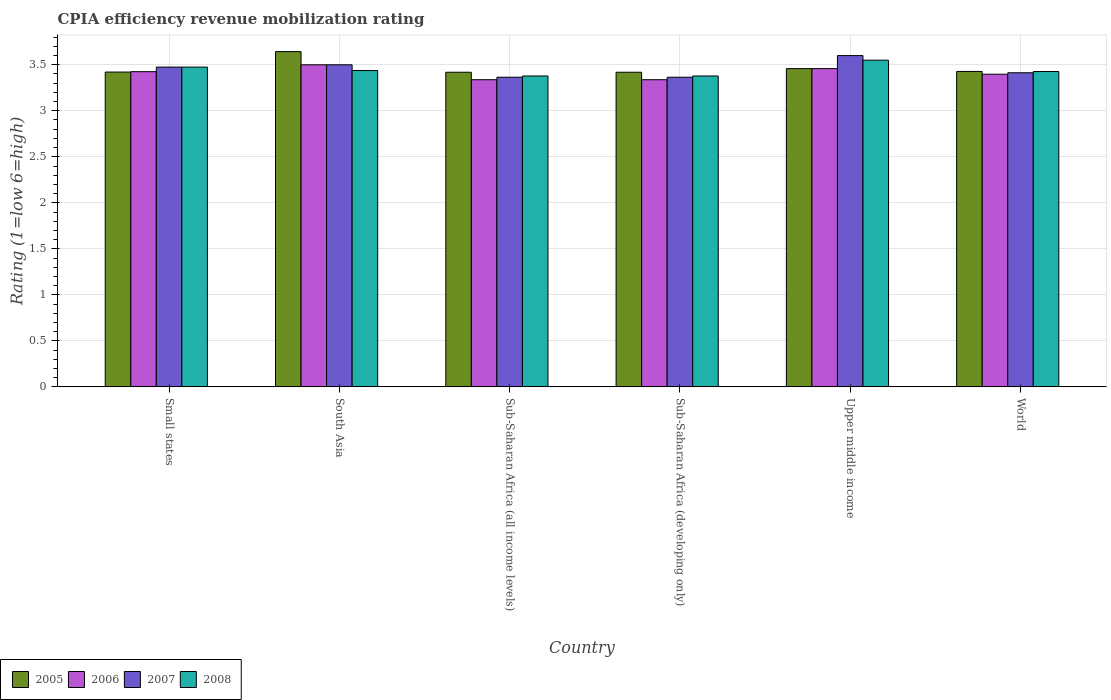How many groups of bars are there?
Provide a short and direct response. 6. Are the number of bars on each tick of the X-axis equal?
Make the answer very short. Yes. How many bars are there on the 5th tick from the left?
Give a very brief answer. 4. What is the label of the 4th group of bars from the left?
Offer a very short reply. Sub-Saharan Africa (developing only). In how many cases, is the number of bars for a given country not equal to the number of legend labels?
Ensure brevity in your answer.  0. What is the CPIA rating in 2005 in Small states?
Provide a short and direct response. 3.42. Across all countries, what is the maximum CPIA rating in 2007?
Provide a short and direct response. 3.6. Across all countries, what is the minimum CPIA rating in 2007?
Provide a succinct answer. 3.36. In which country was the CPIA rating in 2006 minimum?
Ensure brevity in your answer.  Sub-Saharan Africa (all income levels). What is the total CPIA rating in 2006 in the graph?
Make the answer very short. 20.46. What is the difference between the CPIA rating in 2006 in Sub-Saharan Africa (all income levels) and that in World?
Your answer should be very brief. -0.06. What is the difference between the CPIA rating in 2007 in Sub-Saharan Africa (developing only) and the CPIA rating in 2006 in Sub-Saharan Africa (all income levels)?
Offer a terse response. 0.03. What is the average CPIA rating in 2005 per country?
Keep it short and to the point. 3.46. What is the difference between the CPIA rating of/in 2007 and CPIA rating of/in 2005 in Sub-Saharan Africa (developing only)?
Offer a very short reply. -0.05. What is the ratio of the CPIA rating in 2005 in Sub-Saharan Africa (developing only) to that in Upper middle income?
Your answer should be compact. 0.99. Is the difference between the CPIA rating in 2007 in Small states and World greater than the difference between the CPIA rating in 2005 in Small states and World?
Make the answer very short. Yes. What is the difference between the highest and the second highest CPIA rating in 2005?
Your answer should be compact. 0.03. What is the difference between the highest and the lowest CPIA rating in 2008?
Your answer should be compact. 0.17. Is it the case that in every country, the sum of the CPIA rating in 2007 and CPIA rating in 2005 is greater than the sum of CPIA rating in 2008 and CPIA rating in 2006?
Ensure brevity in your answer.  No. What does the 4th bar from the left in South Asia represents?
Your answer should be compact. 2008. Is it the case that in every country, the sum of the CPIA rating in 2008 and CPIA rating in 2005 is greater than the CPIA rating in 2006?
Make the answer very short. Yes. How many bars are there?
Your response must be concise. 24. Are all the bars in the graph horizontal?
Offer a terse response. No. How many countries are there in the graph?
Provide a short and direct response. 6. Does the graph contain any zero values?
Keep it short and to the point. No. How are the legend labels stacked?
Your response must be concise. Horizontal. What is the title of the graph?
Offer a very short reply. CPIA efficiency revenue mobilization rating. Does "2014" appear as one of the legend labels in the graph?
Your answer should be compact. No. What is the Rating (1=low 6=high) of 2005 in Small states?
Your answer should be very brief. 3.42. What is the Rating (1=low 6=high) of 2006 in Small states?
Your response must be concise. 3.42. What is the Rating (1=low 6=high) of 2007 in Small states?
Your answer should be very brief. 3.48. What is the Rating (1=low 6=high) of 2008 in Small states?
Your answer should be compact. 3.48. What is the Rating (1=low 6=high) in 2005 in South Asia?
Provide a short and direct response. 3.64. What is the Rating (1=low 6=high) of 2008 in South Asia?
Provide a short and direct response. 3.44. What is the Rating (1=low 6=high) in 2005 in Sub-Saharan Africa (all income levels)?
Offer a terse response. 3.42. What is the Rating (1=low 6=high) of 2006 in Sub-Saharan Africa (all income levels)?
Offer a very short reply. 3.34. What is the Rating (1=low 6=high) of 2007 in Sub-Saharan Africa (all income levels)?
Give a very brief answer. 3.36. What is the Rating (1=low 6=high) of 2008 in Sub-Saharan Africa (all income levels)?
Your answer should be compact. 3.38. What is the Rating (1=low 6=high) of 2005 in Sub-Saharan Africa (developing only)?
Keep it short and to the point. 3.42. What is the Rating (1=low 6=high) in 2006 in Sub-Saharan Africa (developing only)?
Keep it short and to the point. 3.34. What is the Rating (1=low 6=high) of 2007 in Sub-Saharan Africa (developing only)?
Your answer should be compact. 3.36. What is the Rating (1=low 6=high) in 2008 in Sub-Saharan Africa (developing only)?
Your answer should be very brief. 3.38. What is the Rating (1=low 6=high) of 2005 in Upper middle income?
Your answer should be compact. 3.46. What is the Rating (1=low 6=high) in 2006 in Upper middle income?
Offer a very short reply. 3.46. What is the Rating (1=low 6=high) of 2007 in Upper middle income?
Give a very brief answer. 3.6. What is the Rating (1=low 6=high) in 2008 in Upper middle income?
Provide a succinct answer. 3.55. What is the Rating (1=low 6=high) of 2005 in World?
Provide a succinct answer. 3.43. What is the Rating (1=low 6=high) of 2006 in World?
Keep it short and to the point. 3.4. What is the Rating (1=low 6=high) in 2007 in World?
Offer a terse response. 3.41. What is the Rating (1=low 6=high) of 2008 in World?
Provide a succinct answer. 3.43. Across all countries, what is the maximum Rating (1=low 6=high) in 2005?
Offer a terse response. 3.64. Across all countries, what is the maximum Rating (1=low 6=high) in 2007?
Provide a succinct answer. 3.6. Across all countries, what is the maximum Rating (1=low 6=high) in 2008?
Make the answer very short. 3.55. Across all countries, what is the minimum Rating (1=low 6=high) in 2005?
Offer a very short reply. 3.42. Across all countries, what is the minimum Rating (1=low 6=high) of 2006?
Your answer should be compact. 3.34. Across all countries, what is the minimum Rating (1=low 6=high) of 2007?
Offer a very short reply. 3.36. Across all countries, what is the minimum Rating (1=low 6=high) of 2008?
Your answer should be compact. 3.38. What is the total Rating (1=low 6=high) of 2005 in the graph?
Provide a short and direct response. 20.79. What is the total Rating (1=low 6=high) of 2006 in the graph?
Ensure brevity in your answer.  20.46. What is the total Rating (1=low 6=high) of 2007 in the graph?
Keep it short and to the point. 20.72. What is the total Rating (1=low 6=high) of 2008 in the graph?
Your response must be concise. 20.65. What is the difference between the Rating (1=low 6=high) in 2005 in Small states and that in South Asia?
Your response must be concise. -0.22. What is the difference between the Rating (1=low 6=high) in 2006 in Small states and that in South Asia?
Your answer should be very brief. -0.07. What is the difference between the Rating (1=low 6=high) of 2007 in Small states and that in South Asia?
Offer a terse response. -0.03. What is the difference between the Rating (1=low 6=high) of 2008 in Small states and that in South Asia?
Make the answer very short. 0.04. What is the difference between the Rating (1=low 6=high) in 2005 in Small states and that in Sub-Saharan Africa (all income levels)?
Give a very brief answer. 0. What is the difference between the Rating (1=low 6=high) of 2006 in Small states and that in Sub-Saharan Africa (all income levels)?
Your response must be concise. 0.09. What is the difference between the Rating (1=low 6=high) of 2007 in Small states and that in Sub-Saharan Africa (all income levels)?
Give a very brief answer. 0.11. What is the difference between the Rating (1=low 6=high) of 2008 in Small states and that in Sub-Saharan Africa (all income levels)?
Provide a succinct answer. 0.1. What is the difference between the Rating (1=low 6=high) in 2005 in Small states and that in Sub-Saharan Africa (developing only)?
Keep it short and to the point. 0. What is the difference between the Rating (1=low 6=high) of 2006 in Small states and that in Sub-Saharan Africa (developing only)?
Keep it short and to the point. 0.09. What is the difference between the Rating (1=low 6=high) in 2007 in Small states and that in Sub-Saharan Africa (developing only)?
Ensure brevity in your answer.  0.11. What is the difference between the Rating (1=low 6=high) in 2008 in Small states and that in Sub-Saharan Africa (developing only)?
Provide a short and direct response. 0.1. What is the difference between the Rating (1=low 6=high) in 2005 in Small states and that in Upper middle income?
Make the answer very short. -0.04. What is the difference between the Rating (1=low 6=high) of 2006 in Small states and that in Upper middle income?
Your answer should be compact. -0.03. What is the difference between the Rating (1=low 6=high) in 2007 in Small states and that in Upper middle income?
Offer a terse response. -0.12. What is the difference between the Rating (1=low 6=high) of 2008 in Small states and that in Upper middle income?
Provide a succinct answer. -0.07. What is the difference between the Rating (1=low 6=high) in 2005 in Small states and that in World?
Offer a very short reply. -0.01. What is the difference between the Rating (1=low 6=high) in 2006 in Small states and that in World?
Your response must be concise. 0.03. What is the difference between the Rating (1=low 6=high) in 2007 in Small states and that in World?
Provide a succinct answer. 0.06. What is the difference between the Rating (1=low 6=high) of 2008 in Small states and that in World?
Your response must be concise. 0.05. What is the difference between the Rating (1=low 6=high) of 2005 in South Asia and that in Sub-Saharan Africa (all income levels)?
Ensure brevity in your answer.  0.22. What is the difference between the Rating (1=low 6=high) of 2006 in South Asia and that in Sub-Saharan Africa (all income levels)?
Provide a succinct answer. 0.16. What is the difference between the Rating (1=low 6=high) in 2007 in South Asia and that in Sub-Saharan Africa (all income levels)?
Your answer should be compact. 0.14. What is the difference between the Rating (1=low 6=high) of 2008 in South Asia and that in Sub-Saharan Africa (all income levels)?
Your answer should be compact. 0.06. What is the difference between the Rating (1=low 6=high) of 2005 in South Asia and that in Sub-Saharan Africa (developing only)?
Your answer should be compact. 0.22. What is the difference between the Rating (1=low 6=high) in 2006 in South Asia and that in Sub-Saharan Africa (developing only)?
Ensure brevity in your answer.  0.16. What is the difference between the Rating (1=low 6=high) of 2007 in South Asia and that in Sub-Saharan Africa (developing only)?
Offer a terse response. 0.14. What is the difference between the Rating (1=low 6=high) of 2008 in South Asia and that in Sub-Saharan Africa (developing only)?
Your answer should be very brief. 0.06. What is the difference between the Rating (1=low 6=high) of 2005 in South Asia and that in Upper middle income?
Give a very brief answer. 0.18. What is the difference between the Rating (1=low 6=high) in 2006 in South Asia and that in Upper middle income?
Offer a terse response. 0.04. What is the difference between the Rating (1=low 6=high) in 2008 in South Asia and that in Upper middle income?
Give a very brief answer. -0.11. What is the difference between the Rating (1=low 6=high) in 2005 in South Asia and that in World?
Ensure brevity in your answer.  0.22. What is the difference between the Rating (1=low 6=high) of 2006 in South Asia and that in World?
Ensure brevity in your answer.  0.1. What is the difference between the Rating (1=low 6=high) in 2007 in South Asia and that in World?
Offer a terse response. 0.09. What is the difference between the Rating (1=low 6=high) of 2008 in South Asia and that in World?
Your answer should be very brief. 0.01. What is the difference between the Rating (1=low 6=high) of 2005 in Sub-Saharan Africa (all income levels) and that in Sub-Saharan Africa (developing only)?
Your response must be concise. 0. What is the difference between the Rating (1=low 6=high) in 2007 in Sub-Saharan Africa (all income levels) and that in Sub-Saharan Africa (developing only)?
Your answer should be compact. 0. What is the difference between the Rating (1=low 6=high) in 2008 in Sub-Saharan Africa (all income levels) and that in Sub-Saharan Africa (developing only)?
Your response must be concise. 0. What is the difference between the Rating (1=low 6=high) in 2005 in Sub-Saharan Africa (all income levels) and that in Upper middle income?
Offer a terse response. -0.04. What is the difference between the Rating (1=low 6=high) of 2006 in Sub-Saharan Africa (all income levels) and that in Upper middle income?
Ensure brevity in your answer.  -0.12. What is the difference between the Rating (1=low 6=high) of 2007 in Sub-Saharan Africa (all income levels) and that in Upper middle income?
Make the answer very short. -0.24. What is the difference between the Rating (1=low 6=high) in 2008 in Sub-Saharan Africa (all income levels) and that in Upper middle income?
Give a very brief answer. -0.17. What is the difference between the Rating (1=low 6=high) of 2005 in Sub-Saharan Africa (all income levels) and that in World?
Offer a terse response. -0.01. What is the difference between the Rating (1=low 6=high) in 2006 in Sub-Saharan Africa (all income levels) and that in World?
Your response must be concise. -0.06. What is the difference between the Rating (1=low 6=high) of 2007 in Sub-Saharan Africa (all income levels) and that in World?
Ensure brevity in your answer.  -0.05. What is the difference between the Rating (1=low 6=high) of 2008 in Sub-Saharan Africa (all income levels) and that in World?
Give a very brief answer. -0.05. What is the difference between the Rating (1=low 6=high) of 2005 in Sub-Saharan Africa (developing only) and that in Upper middle income?
Your answer should be compact. -0.04. What is the difference between the Rating (1=low 6=high) in 2006 in Sub-Saharan Africa (developing only) and that in Upper middle income?
Your response must be concise. -0.12. What is the difference between the Rating (1=low 6=high) of 2007 in Sub-Saharan Africa (developing only) and that in Upper middle income?
Your response must be concise. -0.24. What is the difference between the Rating (1=low 6=high) of 2008 in Sub-Saharan Africa (developing only) and that in Upper middle income?
Make the answer very short. -0.17. What is the difference between the Rating (1=low 6=high) in 2005 in Sub-Saharan Africa (developing only) and that in World?
Ensure brevity in your answer.  -0.01. What is the difference between the Rating (1=low 6=high) in 2006 in Sub-Saharan Africa (developing only) and that in World?
Ensure brevity in your answer.  -0.06. What is the difference between the Rating (1=low 6=high) in 2007 in Sub-Saharan Africa (developing only) and that in World?
Offer a terse response. -0.05. What is the difference between the Rating (1=low 6=high) in 2008 in Sub-Saharan Africa (developing only) and that in World?
Give a very brief answer. -0.05. What is the difference between the Rating (1=low 6=high) of 2005 in Upper middle income and that in World?
Make the answer very short. 0.03. What is the difference between the Rating (1=low 6=high) in 2006 in Upper middle income and that in World?
Provide a short and direct response. 0.06. What is the difference between the Rating (1=low 6=high) in 2007 in Upper middle income and that in World?
Give a very brief answer. 0.19. What is the difference between the Rating (1=low 6=high) of 2008 in Upper middle income and that in World?
Your answer should be very brief. 0.12. What is the difference between the Rating (1=low 6=high) in 2005 in Small states and the Rating (1=low 6=high) in 2006 in South Asia?
Keep it short and to the point. -0.08. What is the difference between the Rating (1=low 6=high) of 2005 in Small states and the Rating (1=low 6=high) of 2007 in South Asia?
Provide a succinct answer. -0.08. What is the difference between the Rating (1=low 6=high) in 2005 in Small states and the Rating (1=low 6=high) in 2008 in South Asia?
Your answer should be very brief. -0.02. What is the difference between the Rating (1=low 6=high) of 2006 in Small states and the Rating (1=low 6=high) of 2007 in South Asia?
Your answer should be compact. -0.07. What is the difference between the Rating (1=low 6=high) of 2006 in Small states and the Rating (1=low 6=high) of 2008 in South Asia?
Make the answer very short. -0.01. What is the difference between the Rating (1=low 6=high) of 2007 in Small states and the Rating (1=low 6=high) of 2008 in South Asia?
Your answer should be very brief. 0.04. What is the difference between the Rating (1=low 6=high) of 2005 in Small states and the Rating (1=low 6=high) of 2006 in Sub-Saharan Africa (all income levels)?
Provide a succinct answer. 0.08. What is the difference between the Rating (1=low 6=high) of 2005 in Small states and the Rating (1=low 6=high) of 2007 in Sub-Saharan Africa (all income levels)?
Ensure brevity in your answer.  0.06. What is the difference between the Rating (1=low 6=high) in 2005 in Small states and the Rating (1=low 6=high) in 2008 in Sub-Saharan Africa (all income levels)?
Your answer should be compact. 0.04. What is the difference between the Rating (1=low 6=high) in 2006 in Small states and the Rating (1=low 6=high) in 2007 in Sub-Saharan Africa (all income levels)?
Provide a short and direct response. 0.06. What is the difference between the Rating (1=low 6=high) of 2006 in Small states and the Rating (1=low 6=high) of 2008 in Sub-Saharan Africa (all income levels)?
Your response must be concise. 0.05. What is the difference between the Rating (1=low 6=high) of 2007 in Small states and the Rating (1=low 6=high) of 2008 in Sub-Saharan Africa (all income levels)?
Your answer should be very brief. 0.1. What is the difference between the Rating (1=low 6=high) of 2005 in Small states and the Rating (1=low 6=high) of 2006 in Sub-Saharan Africa (developing only)?
Offer a terse response. 0.08. What is the difference between the Rating (1=low 6=high) of 2005 in Small states and the Rating (1=low 6=high) of 2007 in Sub-Saharan Africa (developing only)?
Ensure brevity in your answer.  0.06. What is the difference between the Rating (1=low 6=high) in 2005 in Small states and the Rating (1=low 6=high) in 2008 in Sub-Saharan Africa (developing only)?
Your response must be concise. 0.04. What is the difference between the Rating (1=low 6=high) of 2006 in Small states and the Rating (1=low 6=high) of 2007 in Sub-Saharan Africa (developing only)?
Ensure brevity in your answer.  0.06. What is the difference between the Rating (1=low 6=high) of 2006 in Small states and the Rating (1=low 6=high) of 2008 in Sub-Saharan Africa (developing only)?
Your answer should be very brief. 0.05. What is the difference between the Rating (1=low 6=high) in 2007 in Small states and the Rating (1=low 6=high) in 2008 in Sub-Saharan Africa (developing only)?
Your response must be concise. 0.1. What is the difference between the Rating (1=low 6=high) in 2005 in Small states and the Rating (1=low 6=high) in 2006 in Upper middle income?
Offer a very short reply. -0.04. What is the difference between the Rating (1=low 6=high) of 2005 in Small states and the Rating (1=low 6=high) of 2007 in Upper middle income?
Your answer should be compact. -0.18. What is the difference between the Rating (1=low 6=high) in 2005 in Small states and the Rating (1=low 6=high) in 2008 in Upper middle income?
Your answer should be very brief. -0.13. What is the difference between the Rating (1=low 6=high) in 2006 in Small states and the Rating (1=low 6=high) in 2007 in Upper middle income?
Give a very brief answer. -0.17. What is the difference between the Rating (1=low 6=high) in 2006 in Small states and the Rating (1=low 6=high) in 2008 in Upper middle income?
Your answer should be compact. -0.12. What is the difference between the Rating (1=low 6=high) of 2007 in Small states and the Rating (1=low 6=high) of 2008 in Upper middle income?
Your answer should be compact. -0.07. What is the difference between the Rating (1=low 6=high) of 2005 in Small states and the Rating (1=low 6=high) of 2006 in World?
Offer a very short reply. 0.02. What is the difference between the Rating (1=low 6=high) in 2005 in Small states and the Rating (1=low 6=high) in 2007 in World?
Provide a short and direct response. 0.01. What is the difference between the Rating (1=low 6=high) of 2005 in Small states and the Rating (1=low 6=high) of 2008 in World?
Make the answer very short. -0.01. What is the difference between the Rating (1=low 6=high) in 2006 in Small states and the Rating (1=low 6=high) in 2007 in World?
Your answer should be compact. 0.01. What is the difference between the Rating (1=low 6=high) of 2006 in Small states and the Rating (1=low 6=high) of 2008 in World?
Your answer should be very brief. -0. What is the difference between the Rating (1=low 6=high) in 2007 in Small states and the Rating (1=low 6=high) in 2008 in World?
Ensure brevity in your answer.  0.05. What is the difference between the Rating (1=low 6=high) in 2005 in South Asia and the Rating (1=low 6=high) in 2006 in Sub-Saharan Africa (all income levels)?
Give a very brief answer. 0.3. What is the difference between the Rating (1=low 6=high) in 2005 in South Asia and the Rating (1=low 6=high) in 2007 in Sub-Saharan Africa (all income levels)?
Give a very brief answer. 0.28. What is the difference between the Rating (1=low 6=high) in 2005 in South Asia and the Rating (1=low 6=high) in 2008 in Sub-Saharan Africa (all income levels)?
Your answer should be very brief. 0.26. What is the difference between the Rating (1=low 6=high) in 2006 in South Asia and the Rating (1=low 6=high) in 2007 in Sub-Saharan Africa (all income levels)?
Provide a succinct answer. 0.14. What is the difference between the Rating (1=low 6=high) in 2006 in South Asia and the Rating (1=low 6=high) in 2008 in Sub-Saharan Africa (all income levels)?
Provide a succinct answer. 0.12. What is the difference between the Rating (1=low 6=high) in 2007 in South Asia and the Rating (1=low 6=high) in 2008 in Sub-Saharan Africa (all income levels)?
Your answer should be compact. 0.12. What is the difference between the Rating (1=low 6=high) in 2005 in South Asia and the Rating (1=low 6=high) in 2006 in Sub-Saharan Africa (developing only)?
Make the answer very short. 0.3. What is the difference between the Rating (1=low 6=high) in 2005 in South Asia and the Rating (1=low 6=high) in 2007 in Sub-Saharan Africa (developing only)?
Ensure brevity in your answer.  0.28. What is the difference between the Rating (1=low 6=high) of 2005 in South Asia and the Rating (1=low 6=high) of 2008 in Sub-Saharan Africa (developing only)?
Provide a short and direct response. 0.26. What is the difference between the Rating (1=low 6=high) in 2006 in South Asia and the Rating (1=low 6=high) in 2007 in Sub-Saharan Africa (developing only)?
Give a very brief answer. 0.14. What is the difference between the Rating (1=low 6=high) in 2006 in South Asia and the Rating (1=low 6=high) in 2008 in Sub-Saharan Africa (developing only)?
Offer a terse response. 0.12. What is the difference between the Rating (1=low 6=high) in 2007 in South Asia and the Rating (1=low 6=high) in 2008 in Sub-Saharan Africa (developing only)?
Provide a short and direct response. 0.12. What is the difference between the Rating (1=low 6=high) of 2005 in South Asia and the Rating (1=low 6=high) of 2006 in Upper middle income?
Provide a short and direct response. 0.18. What is the difference between the Rating (1=low 6=high) of 2005 in South Asia and the Rating (1=low 6=high) of 2007 in Upper middle income?
Provide a short and direct response. 0.04. What is the difference between the Rating (1=low 6=high) of 2005 in South Asia and the Rating (1=low 6=high) of 2008 in Upper middle income?
Your answer should be compact. 0.09. What is the difference between the Rating (1=low 6=high) of 2006 in South Asia and the Rating (1=low 6=high) of 2008 in Upper middle income?
Provide a succinct answer. -0.05. What is the difference between the Rating (1=low 6=high) in 2005 in South Asia and the Rating (1=low 6=high) in 2006 in World?
Make the answer very short. 0.25. What is the difference between the Rating (1=low 6=high) in 2005 in South Asia and the Rating (1=low 6=high) in 2007 in World?
Offer a very short reply. 0.23. What is the difference between the Rating (1=low 6=high) of 2005 in South Asia and the Rating (1=low 6=high) of 2008 in World?
Provide a short and direct response. 0.22. What is the difference between the Rating (1=low 6=high) of 2006 in South Asia and the Rating (1=low 6=high) of 2007 in World?
Your answer should be very brief. 0.09. What is the difference between the Rating (1=low 6=high) in 2006 in South Asia and the Rating (1=low 6=high) in 2008 in World?
Keep it short and to the point. 0.07. What is the difference between the Rating (1=low 6=high) in 2007 in South Asia and the Rating (1=low 6=high) in 2008 in World?
Give a very brief answer. 0.07. What is the difference between the Rating (1=low 6=high) of 2005 in Sub-Saharan Africa (all income levels) and the Rating (1=low 6=high) of 2006 in Sub-Saharan Africa (developing only)?
Offer a very short reply. 0.08. What is the difference between the Rating (1=low 6=high) of 2005 in Sub-Saharan Africa (all income levels) and the Rating (1=low 6=high) of 2007 in Sub-Saharan Africa (developing only)?
Your answer should be very brief. 0.05. What is the difference between the Rating (1=low 6=high) in 2005 in Sub-Saharan Africa (all income levels) and the Rating (1=low 6=high) in 2008 in Sub-Saharan Africa (developing only)?
Offer a very short reply. 0.04. What is the difference between the Rating (1=low 6=high) of 2006 in Sub-Saharan Africa (all income levels) and the Rating (1=low 6=high) of 2007 in Sub-Saharan Africa (developing only)?
Give a very brief answer. -0.03. What is the difference between the Rating (1=low 6=high) in 2006 in Sub-Saharan Africa (all income levels) and the Rating (1=low 6=high) in 2008 in Sub-Saharan Africa (developing only)?
Provide a short and direct response. -0.04. What is the difference between the Rating (1=low 6=high) of 2007 in Sub-Saharan Africa (all income levels) and the Rating (1=low 6=high) of 2008 in Sub-Saharan Africa (developing only)?
Provide a short and direct response. -0.01. What is the difference between the Rating (1=low 6=high) in 2005 in Sub-Saharan Africa (all income levels) and the Rating (1=low 6=high) in 2006 in Upper middle income?
Ensure brevity in your answer.  -0.04. What is the difference between the Rating (1=low 6=high) in 2005 in Sub-Saharan Africa (all income levels) and the Rating (1=low 6=high) in 2007 in Upper middle income?
Make the answer very short. -0.18. What is the difference between the Rating (1=low 6=high) in 2005 in Sub-Saharan Africa (all income levels) and the Rating (1=low 6=high) in 2008 in Upper middle income?
Offer a very short reply. -0.13. What is the difference between the Rating (1=low 6=high) in 2006 in Sub-Saharan Africa (all income levels) and the Rating (1=low 6=high) in 2007 in Upper middle income?
Make the answer very short. -0.26. What is the difference between the Rating (1=low 6=high) of 2006 in Sub-Saharan Africa (all income levels) and the Rating (1=low 6=high) of 2008 in Upper middle income?
Offer a very short reply. -0.21. What is the difference between the Rating (1=low 6=high) of 2007 in Sub-Saharan Africa (all income levels) and the Rating (1=low 6=high) of 2008 in Upper middle income?
Make the answer very short. -0.19. What is the difference between the Rating (1=low 6=high) in 2005 in Sub-Saharan Africa (all income levels) and the Rating (1=low 6=high) in 2006 in World?
Your answer should be compact. 0.02. What is the difference between the Rating (1=low 6=high) of 2005 in Sub-Saharan Africa (all income levels) and the Rating (1=low 6=high) of 2007 in World?
Offer a very short reply. 0.01. What is the difference between the Rating (1=low 6=high) in 2005 in Sub-Saharan Africa (all income levels) and the Rating (1=low 6=high) in 2008 in World?
Ensure brevity in your answer.  -0.01. What is the difference between the Rating (1=low 6=high) of 2006 in Sub-Saharan Africa (all income levels) and the Rating (1=low 6=high) of 2007 in World?
Keep it short and to the point. -0.08. What is the difference between the Rating (1=low 6=high) of 2006 in Sub-Saharan Africa (all income levels) and the Rating (1=low 6=high) of 2008 in World?
Your answer should be compact. -0.09. What is the difference between the Rating (1=low 6=high) of 2007 in Sub-Saharan Africa (all income levels) and the Rating (1=low 6=high) of 2008 in World?
Make the answer very short. -0.06. What is the difference between the Rating (1=low 6=high) of 2005 in Sub-Saharan Africa (developing only) and the Rating (1=low 6=high) of 2006 in Upper middle income?
Provide a short and direct response. -0.04. What is the difference between the Rating (1=low 6=high) of 2005 in Sub-Saharan Africa (developing only) and the Rating (1=low 6=high) of 2007 in Upper middle income?
Keep it short and to the point. -0.18. What is the difference between the Rating (1=low 6=high) of 2005 in Sub-Saharan Africa (developing only) and the Rating (1=low 6=high) of 2008 in Upper middle income?
Provide a succinct answer. -0.13. What is the difference between the Rating (1=low 6=high) of 2006 in Sub-Saharan Africa (developing only) and the Rating (1=low 6=high) of 2007 in Upper middle income?
Give a very brief answer. -0.26. What is the difference between the Rating (1=low 6=high) of 2006 in Sub-Saharan Africa (developing only) and the Rating (1=low 6=high) of 2008 in Upper middle income?
Provide a short and direct response. -0.21. What is the difference between the Rating (1=low 6=high) of 2007 in Sub-Saharan Africa (developing only) and the Rating (1=low 6=high) of 2008 in Upper middle income?
Your answer should be very brief. -0.19. What is the difference between the Rating (1=low 6=high) of 2005 in Sub-Saharan Africa (developing only) and the Rating (1=low 6=high) of 2006 in World?
Offer a terse response. 0.02. What is the difference between the Rating (1=low 6=high) in 2005 in Sub-Saharan Africa (developing only) and the Rating (1=low 6=high) in 2007 in World?
Your answer should be very brief. 0.01. What is the difference between the Rating (1=low 6=high) in 2005 in Sub-Saharan Africa (developing only) and the Rating (1=low 6=high) in 2008 in World?
Provide a succinct answer. -0.01. What is the difference between the Rating (1=low 6=high) in 2006 in Sub-Saharan Africa (developing only) and the Rating (1=low 6=high) in 2007 in World?
Provide a short and direct response. -0.08. What is the difference between the Rating (1=low 6=high) in 2006 in Sub-Saharan Africa (developing only) and the Rating (1=low 6=high) in 2008 in World?
Your answer should be very brief. -0.09. What is the difference between the Rating (1=low 6=high) in 2007 in Sub-Saharan Africa (developing only) and the Rating (1=low 6=high) in 2008 in World?
Provide a succinct answer. -0.06. What is the difference between the Rating (1=low 6=high) in 2005 in Upper middle income and the Rating (1=low 6=high) in 2006 in World?
Provide a succinct answer. 0.06. What is the difference between the Rating (1=low 6=high) in 2005 in Upper middle income and the Rating (1=low 6=high) in 2007 in World?
Keep it short and to the point. 0.04. What is the difference between the Rating (1=low 6=high) in 2005 in Upper middle income and the Rating (1=low 6=high) in 2008 in World?
Provide a short and direct response. 0.03. What is the difference between the Rating (1=low 6=high) in 2006 in Upper middle income and the Rating (1=low 6=high) in 2007 in World?
Keep it short and to the point. 0.04. What is the difference between the Rating (1=low 6=high) in 2006 in Upper middle income and the Rating (1=low 6=high) in 2008 in World?
Ensure brevity in your answer.  0.03. What is the difference between the Rating (1=low 6=high) in 2007 in Upper middle income and the Rating (1=low 6=high) in 2008 in World?
Provide a short and direct response. 0.17. What is the average Rating (1=low 6=high) in 2005 per country?
Offer a very short reply. 3.46. What is the average Rating (1=low 6=high) of 2006 per country?
Offer a terse response. 3.41. What is the average Rating (1=low 6=high) in 2007 per country?
Offer a terse response. 3.45. What is the average Rating (1=low 6=high) of 2008 per country?
Provide a short and direct response. 3.44. What is the difference between the Rating (1=low 6=high) in 2005 and Rating (1=low 6=high) in 2006 in Small states?
Provide a succinct answer. -0. What is the difference between the Rating (1=low 6=high) of 2005 and Rating (1=low 6=high) of 2007 in Small states?
Keep it short and to the point. -0.05. What is the difference between the Rating (1=low 6=high) of 2005 and Rating (1=low 6=high) of 2008 in Small states?
Provide a short and direct response. -0.05. What is the difference between the Rating (1=low 6=high) in 2005 and Rating (1=low 6=high) in 2006 in South Asia?
Give a very brief answer. 0.14. What is the difference between the Rating (1=low 6=high) of 2005 and Rating (1=low 6=high) of 2007 in South Asia?
Your answer should be compact. 0.14. What is the difference between the Rating (1=low 6=high) of 2005 and Rating (1=low 6=high) of 2008 in South Asia?
Give a very brief answer. 0.21. What is the difference between the Rating (1=low 6=high) of 2006 and Rating (1=low 6=high) of 2008 in South Asia?
Your response must be concise. 0.06. What is the difference between the Rating (1=low 6=high) of 2007 and Rating (1=low 6=high) of 2008 in South Asia?
Your response must be concise. 0.06. What is the difference between the Rating (1=low 6=high) in 2005 and Rating (1=low 6=high) in 2006 in Sub-Saharan Africa (all income levels)?
Provide a short and direct response. 0.08. What is the difference between the Rating (1=low 6=high) of 2005 and Rating (1=low 6=high) of 2007 in Sub-Saharan Africa (all income levels)?
Your answer should be very brief. 0.05. What is the difference between the Rating (1=low 6=high) in 2005 and Rating (1=low 6=high) in 2008 in Sub-Saharan Africa (all income levels)?
Offer a very short reply. 0.04. What is the difference between the Rating (1=low 6=high) of 2006 and Rating (1=low 6=high) of 2007 in Sub-Saharan Africa (all income levels)?
Offer a terse response. -0.03. What is the difference between the Rating (1=low 6=high) in 2006 and Rating (1=low 6=high) in 2008 in Sub-Saharan Africa (all income levels)?
Your answer should be compact. -0.04. What is the difference between the Rating (1=low 6=high) in 2007 and Rating (1=low 6=high) in 2008 in Sub-Saharan Africa (all income levels)?
Offer a terse response. -0.01. What is the difference between the Rating (1=low 6=high) in 2005 and Rating (1=low 6=high) in 2006 in Sub-Saharan Africa (developing only)?
Give a very brief answer. 0.08. What is the difference between the Rating (1=low 6=high) of 2005 and Rating (1=low 6=high) of 2007 in Sub-Saharan Africa (developing only)?
Your answer should be compact. 0.05. What is the difference between the Rating (1=low 6=high) of 2005 and Rating (1=low 6=high) of 2008 in Sub-Saharan Africa (developing only)?
Offer a terse response. 0.04. What is the difference between the Rating (1=low 6=high) in 2006 and Rating (1=low 6=high) in 2007 in Sub-Saharan Africa (developing only)?
Your answer should be compact. -0.03. What is the difference between the Rating (1=low 6=high) of 2006 and Rating (1=low 6=high) of 2008 in Sub-Saharan Africa (developing only)?
Offer a terse response. -0.04. What is the difference between the Rating (1=low 6=high) in 2007 and Rating (1=low 6=high) in 2008 in Sub-Saharan Africa (developing only)?
Give a very brief answer. -0.01. What is the difference between the Rating (1=low 6=high) in 2005 and Rating (1=low 6=high) in 2006 in Upper middle income?
Your response must be concise. 0. What is the difference between the Rating (1=low 6=high) in 2005 and Rating (1=low 6=high) in 2007 in Upper middle income?
Provide a succinct answer. -0.14. What is the difference between the Rating (1=low 6=high) in 2005 and Rating (1=low 6=high) in 2008 in Upper middle income?
Provide a succinct answer. -0.09. What is the difference between the Rating (1=low 6=high) in 2006 and Rating (1=low 6=high) in 2007 in Upper middle income?
Give a very brief answer. -0.14. What is the difference between the Rating (1=low 6=high) of 2006 and Rating (1=low 6=high) of 2008 in Upper middle income?
Offer a very short reply. -0.09. What is the difference between the Rating (1=low 6=high) in 2007 and Rating (1=low 6=high) in 2008 in Upper middle income?
Your response must be concise. 0.05. What is the difference between the Rating (1=low 6=high) in 2005 and Rating (1=low 6=high) in 2006 in World?
Give a very brief answer. 0.03. What is the difference between the Rating (1=low 6=high) in 2005 and Rating (1=low 6=high) in 2007 in World?
Offer a very short reply. 0.01. What is the difference between the Rating (1=low 6=high) of 2005 and Rating (1=low 6=high) of 2008 in World?
Keep it short and to the point. 0. What is the difference between the Rating (1=low 6=high) in 2006 and Rating (1=low 6=high) in 2007 in World?
Provide a short and direct response. -0.02. What is the difference between the Rating (1=low 6=high) of 2006 and Rating (1=low 6=high) of 2008 in World?
Offer a terse response. -0.03. What is the difference between the Rating (1=low 6=high) of 2007 and Rating (1=low 6=high) of 2008 in World?
Provide a short and direct response. -0.01. What is the ratio of the Rating (1=low 6=high) in 2005 in Small states to that in South Asia?
Provide a succinct answer. 0.94. What is the ratio of the Rating (1=low 6=high) in 2006 in Small states to that in South Asia?
Your answer should be compact. 0.98. What is the ratio of the Rating (1=low 6=high) in 2007 in Small states to that in South Asia?
Offer a very short reply. 0.99. What is the ratio of the Rating (1=low 6=high) of 2008 in Small states to that in South Asia?
Provide a short and direct response. 1.01. What is the ratio of the Rating (1=low 6=high) in 2005 in Small states to that in Sub-Saharan Africa (all income levels)?
Your answer should be compact. 1. What is the ratio of the Rating (1=low 6=high) of 2006 in Small states to that in Sub-Saharan Africa (all income levels)?
Provide a short and direct response. 1.03. What is the ratio of the Rating (1=low 6=high) in 2007 in Small states to that in Sub-Saharan Africa (all income levels)?
Keep it short and to the point. 1.03. What is the ratio of the Rating (1=low 6=high) of 2008 in Small states to that in Sub-Saharan Africa (all income levels)?
Give a very brief answer. 1.03. What is the ratio of the Rating (1=low 6=high) in 2005 in Small states to that in Sub-Saharan Africa (developing only)?
Offer a very short reply. 1. What is the ratio of the Rating (1=low 6=high) of 2006 in Small states to that in Sub-Saharan Africa (developing only)?
Your answer should be compact. 1.03. What is the ratio of the Rating (1=low 6=high) of 2007 in Small states to that in Sub-Saharan Africa (developing only)?
Provide a short and direct response. 1.03. What is the ratio of the Rating (1=low 6=high) in 2008 in Small states to that in Sub-Saharan Africa (developing only)?
Offer a terse response. 1.03. What is the ratio of the Rating (1=low 6=high) in 2005 in Small states to that in Upper middle income?
Your answer should be compact. 0.99. What is the ratio of the Rating (1=low 6=high) of 2007 in Small states to that in Upper middle income?
Offer a very short reply. 0.97. What is the ratio of the Rating (1=low 6=high) in 2008 in Small states to that in Upper middle income?
Give a very brief answer. 0.98. What is the ratio of the Rating (1=low 6=high) of 2005 in Small states to that in World?
Your response must be concise. 1. What is the ratio of the Rating (1=low 6=high) of 2007 in Small states to that in World?
Provide a short and direct response. 1.02. What is the ratio of the Rating (1=low 6=high) in 2008 in Small states to that in World?
Give a very brief answer. 1.01. What is the ratio of the Rating (1=low 6=high) in 2005 in South Asia to that in Sub-Saharan Africa (all income levels)?
Provide a short and direct response. 1.07. What is the ratio of the Rating (1=low 6=high) in 2006 in South Asia to that in Sub-Saharan Africa (all income levels)?
Ensure brevity in your answer.  1.05. What is the ratio of the Rating (1=low 6=high) of 2007 in South Asia to that in Sub-Saharan Africa (all income levels)?
Keep it short and to the point. 1.04. What is the ratio of the Rating (1=low 6=high) in 2008 in South Asia to that in Sub-Saharan Africa (all income levels)?
Offer a terse response. 1.02. What is the ratio of the Rating (1=low 6=high) of 2005 in South Asia to that in Sub-Saharan Africa (developing only)?
Offer a terse response. 1.07. What is the ratio of the Rating (1=low 6=high) of 2006 in South Asia to that in Sub-Saharan Africa (developing only)?
Keep it short and to the point. 1.05. What is the ratio of the Rating (1=low 6=high) in 2007 in South Asia to that in Sub-Saharan Africa (developing only)?
Ensure brevity in your answer.  1.04. What is the ratio of the Rating (1=low 6=high) in 2008 in South Asia to that in Sub-Saharan Africa (developing only)?
Your response must be concise. 1.02. What is the ratio of the Rating (1=low 6=high) in 2005 in South Asia to that in Upper middle income?
Your response must be concise. 1.05. What is the ratio of the Rating (1=low 6=high) of 2006 in South Asia to that in Upper middle income?
Provide a succinct answer. 1.01. What is the ratio of the Rating (1=low 6=high) in 2007 in South Asia to that in Upper middle income?
Ensure brevity in your answer.  0.97. What is the ratio of the Rating (1=low 6=high) of 2008 in South Asia to that in Upper middle income?
Give a very brief answer. 0.97. What is the ratio of the Rating (1=low 6=high) in 2005 in South Asia to that in World?
Give a very brief answer. 1.06. What is the ratio of the Rating (1=low 6=high) of 2006 in South Asia to that in World?
Ensure brevity in your answer.  1.03. What is the ratio of the Rating (1=low 6=high) of 2007 in South Asia to that in World?
Your answer should be compact. 1.03. What is the ratio of the Rating (1=low 6=high) in 2005 in Sub-Saharan Africa (all income levels) to that in Sub-Saharan Africa (developing only)?
Ensure brevity in your answer.  1. What is the ratio of the Rating (1=low 6=high) in 2007 in Sub-Saharan Africa (all income levels) to that in Sub-Saharan Africa (developing only)?
Give a very brief answer. 1. What is the ratio of the Rating (1=low 6=high) of 2006 in Sub-Saharan Africa (all income levels) to that in Upper middle income?
Provide a short and direct response. 0.97. What is the ratio of the Rating (1=low 6=high) in 2007 in Sub-Saharan Africa (all income levels) to that in Upper middle income?
Keep it short and to the point. 0.93. What is the ratio of the Rating (1=low 6=high) in 2008 in Sub-Saharan Africa (all income levels) to that in Upper middle income?
Keep it short and to the point. 0.95. What is the ratio of the Rating (1=low 6=high) of 2006 in Sub-Saharan Africa (all income levels) to that in World?
Offer a very short reply. 0.98. What is the ratio of the Rating (1=low 6=high) of 2007 in Sub-Saharan Africa (all income levels) to that in World?
Offer a very short reply. 0.99. What is the ratio of the Rating (1=low 6=high) of 2008 in Sub-Saharan Africa (all income levels) to that in World?
Keep it short and to the point. 0.99. What is the ratio of the Rating (1=low 6=high) in 2006 in Sub-Saharan Africa (developing only) to that in Upper middle income?
Offer a terse response. 0.97. What is the ratio of the Rating (1=low 6=high) of 2007 in Sub-Saharan Africa (developing only) to that in Upper middle income?
Keep it short and to the point. 0.93. What is the ratio of the Rating (1=low 6=high) of 2008 in Sub-Saharan Africa (developing only) to that in Upper middle income?
Offer a terse response. 0.95. What is the ratio of the Rating (1=low 6=high) of 2005 in Sub-Saharan Africa (developing only) to that in World?
Give a very brief answer. 1. What is the ratio of the Rating (1=low 6=high) of 2006 in Sub-Saharan Africa (developing only) to that in World?
Provide a succinct answer. 0.98. What is the ratio of the Rating (1=low 6=high) in 2007 in Sub-Saharan Africa (developing only) to that in World?
Ensure brevity in your answer.  0.99. What is the ratio of the Rating (1=low 6=high) of 2008 in Sub-Saharan Africa (developing only) to that in World?
Make the answer very short. 0.99. What is the ratio of the Rating (1=low 6=high) of 2005 in Upper middle income to that in World?
Give a very brief answer. 1.01. What is the ratio of the Rating (1=low 6=high) in 2006 in Upper middle income to that in World?
Provide a succinct answer. 1.02. What is the ratio of the Rating (1=low 6=high) of 2007 in Upper middle income to that in World?
Your response must be concise. 1.05. What is the ratio of the Rating (1=low 6=high) of 2008 in Upper middle income to that in World?
Provide a short and direct response. 1.04. What is the difference between the highest and the second highest Rating (1=low 6=high) of 2005?
Your answer should be compact. 0.18. What is the difference between the highest and the second highest Rating (1=low 6=high) in 2006?
Keep it short and to the point. 0.04. What is the difference between the highest and the second highest Rating (1=low 6=high) of 2007?
Offer a terse response. 0.1. What is the difference between the highest and the second highest Rating (1=low 6=high) in 2008?
Make the answer very short. 0.07. What is the difference between the highest and the lowest Rating (1=low 6=high) of 2005?
Provide a succinct answer. 0.22. What is the difference between the highest and the lowest Rating (1=low 6=high) in 2006?
Make the answer very short. 0.16. What is the difference between the highest and the lowest Rating (1=low 6=high) of 2007?
Provide a succinct answer. 0.24. What is the difference between the highest and the lowest Rating (1=low 6=high) in 2008?
Give a very brief answer. 0.17. 